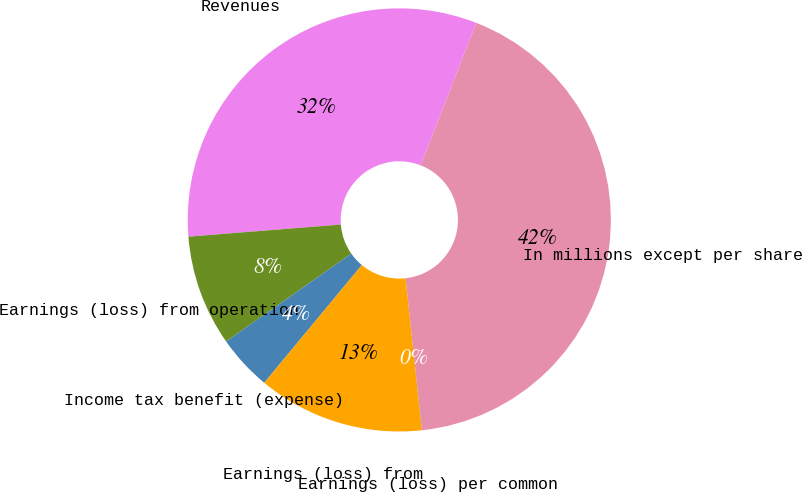Convert chart. <chart><loc_0><loc_0><loc_500><loc_500><pie_chart><fcel>In millions except per share<fcel>Revenues<fcel>Earnings (loss) from operation<fcel>Income tax benefit (expense)<fcel>Earnings (loss) from<fcel>Earnings (loss) per common<nl><fcel>42.37%<fcel>32.18%<fcel>8.48%<fcel>4.24%<fcel>12.72%<fcel>0.01%<nl></chart> 